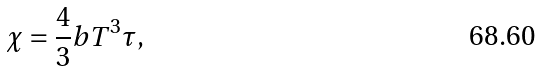<formula> <loc_0><loc_0><loc_500><loc_500>\chi = \frac { 4 } { 3 } b T ^ { 3 } \tau ,</formula> 